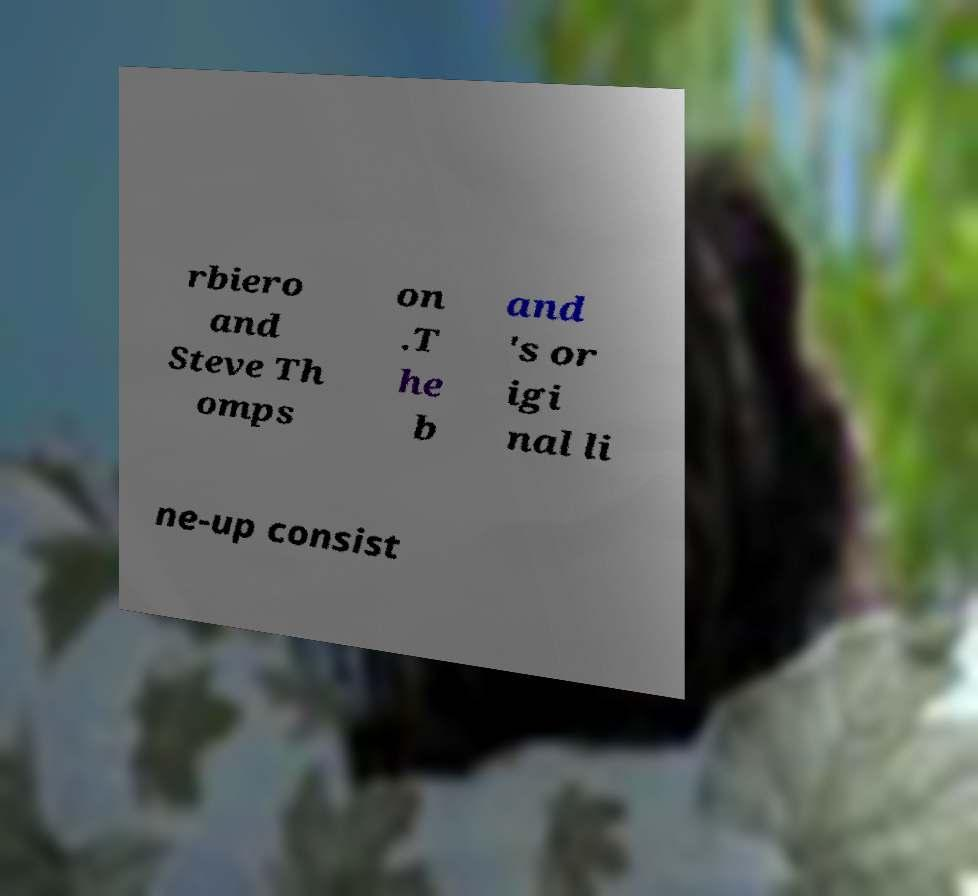Could you extract and type out the text from this image? rbiero and Steve Th omps on .T he b and 's or igi nal li ne-up consist 